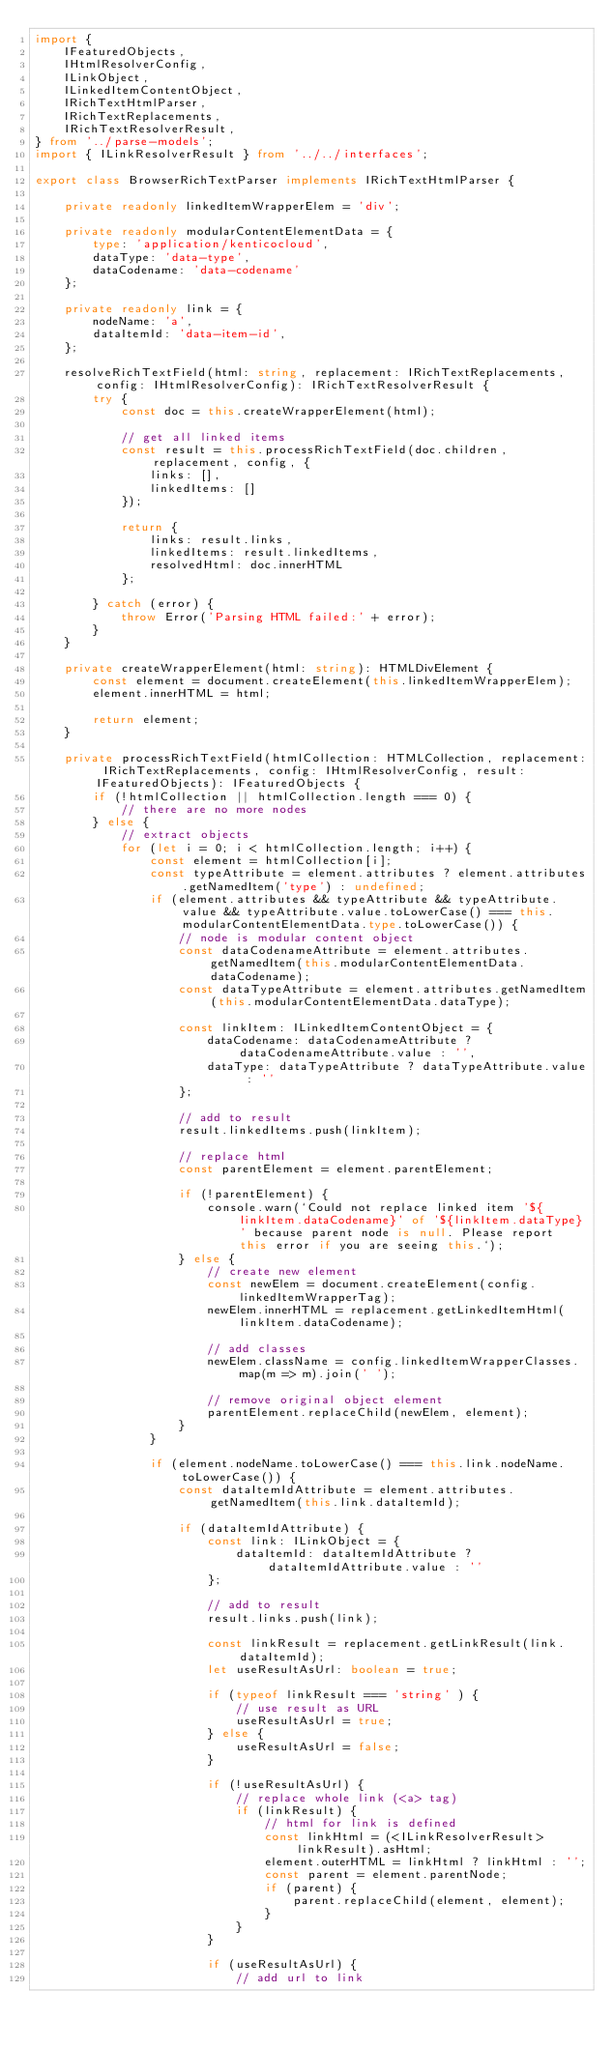<code> <loc_0><loc_0><loc_500><loc_500><_TypeScript_>import {
    IFeaturedObjects,
    IHtmlResolverConfig,
    ILinkObject,
    ILinkedItemContentObject,
    IRichTextHtmlParser,
    IRichTextReplacements,
    IRichTextResolverResult,
} from '../parse-models';
import { ILinkResolverResult } from '../../interfaces';

export class BrowserRichTextParser implements IRichTextHtmlParser {

    private readonly linkedItemWrapperElem = 'div';

    private readonly modularContentElementData = {
        type: 'application/kenticocloud',
        dataType: 'data-type',
        dataCodename: 'data-codename'
    };

    private readonly link = {
        nodeName: 'a',
        dataItemId: 'data-item-id',
    };

    resolveRichTextField(html: string, replacement: IRichTextReplacements, config: IHtmlResolverConfig): IRichTextResolverResult {
        try {
            const doc = this.createWrapperElement(html);

            // get all linked items
            const result = this.processRichTextField(doc.children, replacement, config, {
                links: [],
                linkedItems: []
            });

            return {
                links: result.links,
                linkedItems: result.linkedItems,
                resolvedHtml: doc.innerHTML
            };

        } catch (error) {
            throw Error('Parsing HTML failed:' + error);
        }
    }

    private createWrapperElement(html: string): HTMLDivElement {
        const element = document.createElement(this.linkedItemWrapperElem);
        element.innerHTML = html;

        return element;
    }

    private processRichTextField(htmlCollection: HTMLCollection, replacement: IRichTextReplacements, config: IHtmlResolverConfig, result: IFeaturedObjects): IFeaturedObjects {
        if (!htmlCollection || htmlCollection.length === 0) {
            // there are no more nodes
        } else {
            // extract objects
            for (let i = 0; i < htmlCollection.length; i++) {
                const element = htmlCollection[i];
                const typeAttribute = element.attributes ? element.attributes.getNamedItem('type') : undefined;
                if (element.attributes && typeAttribute && typeAttribute.value && typeAttribute.value.toLowerCase() === this.modularContentElementData.type.toLowerCase()) {
                    // node is modular content object
                    const dataCodenameAttribute = element.attributes.getNamedItem(this.modularContentElementData.dataCodename);
                    const dataTypeAttribute = element.attributes.getNamedItem(this.modularContentElementData.dataType);

                    const linkItem: ILinkedItemContentObject = {
                        dataCodename: dataCodenameAttribute ? dataCodenameAttribute.value : '',
                        dataType: dataTypeAttribute ? dataTypeAttribute.value : ''
                    };

                    // add to result
                    result.linkedItems.push(linkItem);

                    // replace html
                    const parentElement = element.parentElement;

                    if (!parentElement) {
                        console.warn(`Could not replace linked item '${linkItem.dataCodename}' of '${linkItem.dataType}' because parent node is null. Please report this error if you are seeing this.`);
                    } else {
                        // create new element
                        const newElem = document.createElement(config.linkedItemWrapperTag);
                        newElem.innerHTML = replacement.getLinkedItemHtml(linkItem.dataCodename);

                        // add classes
                        newElem.className = config.linkedItemWrapperClasses.map(m => m).join(' ');

                        // remove original object element
                        parentElement.replaceChild(newElem, element);
                    }
                }

                if (element.nodeName.toLowerCase() === this.link.nodeName.toLowerCase()) {
                    const dataItemIdAttribute = element.attributes.getNamedItem(this.link.dataItemId);

                    if (dataItemIdAttribute) {
                        const link: ILinkObject = {
                            dataItemId: dataItemIdAttribute ? dataItemIdAttribute.value : ''
                        };

                        // add to result
                        result.links.push(link);

                        const linkResult = replacement.getLinkResult(link.dataItemId);
                        let useResultAsUrl: boolean = true;

                        if (typeof linkResult === 'string' ) {
                            // use result as URL
                            useResultAsUrl = true;
                        } else {
                            useResultAsUrl = false;
                        }

                        if (!useResultAsUrl) {
                            // replace whole link (<a> tag)
                            if (linkResult) {
                                // html for link is defined
                                const linkHtml = (<ILinkResolverResult>linkResult).asHtml;
                                element.outerHTML = linkHtml ? linkHtml : '';
                                const parent = element.parentNode;
                                if (parent) {
                                    parent.replaceChild(element, element);
                                }
                            }
                        }

                        if (useResultAsUrl) {
                            // add url to link</code> 